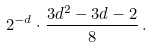Convert formula to latex. <formula><loc_0><loc_0><loc_500><loc_500>2 ^ { - d } \cdot \frac { 3 d ^ { 2 } - 3 d - 2 } { 8 } \, .</formula> 